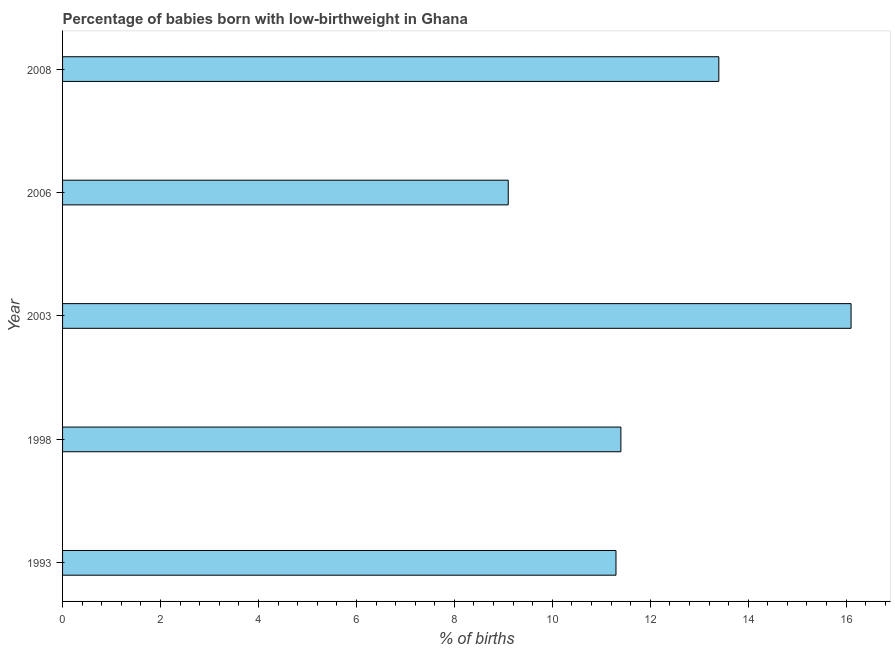Does the graph contain any zero values?
Your answer should be very brief. No. Does the graph contain grids?
Your response must be concise. No. What is the title of the graph?
Make the answer very short. Percentage of babies born with low-birthweight in Ghana. What is the label or title of the X-axis?
Provide a succinct answer. % of births. What is the percentage of babies who were born with low-birthweight in 1998?
Your answer should be compact. 11.4. Across all years, what is the maximum percentage of babies who were born with low-birthweight?
Keep it short and to the point. 16.1. In which year was the percentage of babies who were born with low-birthweight maximum?
Give a very brief answer. 2003. In which year was the percentage of babies who were born with low-birthweight minimum?
Make the answer very short. 2006. What is the sum of the percentage of babies who were born with low-birthweight?
Make the answer very short. 61.3. What is the average percentage of babies who were born with low-birthweight per year?
Offer a terse response. 12.26. In how many years, is the percentage of babies who were born with low-birthweight greater than 11.6 %?
Ensure brevity in your answer.  2. Is the percentage of babies who were born with low-birthweight in 2003 less than that in 2008?
Your answer should be compact. No. Is the difference between the percentage of babies who were born with low-birthweight in 1998 and 2008 greater than the difference between any two years?
Keep it short and to the point. No. What is the difference between the highest and the second highest percentage of babies who were born with low-birthweight?
Keep it short and to the point. 2.7. In how many years, is the percentage of babies who were born with low-birthweight greater than the average percentage of babies who were born with low-birthweight taken over all years?
Give a very brief answer. 2. Are all the bars in the graph horizontal?
Provide a succinct answer. Yes. What is the % of births of 1993?
Your response must be concise. 11.3. What is the % of births in 1998?
Ensure brevity in your answer.  11.4. What is the difference between the % of births in 1993 and 1998?
Your answer should be very brief. -0.1. What is the difference between the % of births in 1993 and 2003?
Give a very brief answer. -4.8. What is the difference between the % of births in 1993 and 2008?
Keep it short and to the point. -2.1. What is the difference between the % of births in 1998 and 2006?
Offer a very short reply. 2.3. What is the difference between the % of births in 2003 and 2006?
Make the answer very short. 7. What is the ratio of the % of births in 1993 to that in 1998?
Your answer should be very brief. 0.99. What is the ratio of the % of births in 1993 to that in 2003?
Your answer should be compact. 0.7. What is the ratio of the % of births in 1993 to that in 2006?
Provide a succinct answer. 1.24. What is the ratio of the % of births in 1993 to that in 2008?
Make the answer very short. 0.84. What is the ratio of the % of births in 1998 to that in 2003?
Ensure brevity in your answer.  0.71. What is the ratio of the % of births in 1998 to that in 2006?
Make the answer very short. 1.25. What is the ratio of the % of births in 1998 to that in 2008?
Your response must be concise. 0.85. What is the ratio of the % of births in 2003 to that in 2006?
Your answer should be compact. 1.77. What is the ratio of the % of births in 2003 to that in 2008?
Ensure brevity in your answer.  1.2. What is the ratio of the % of births in 2006 to that in 2008?
Ensure brevity in your answer.  0.68. 